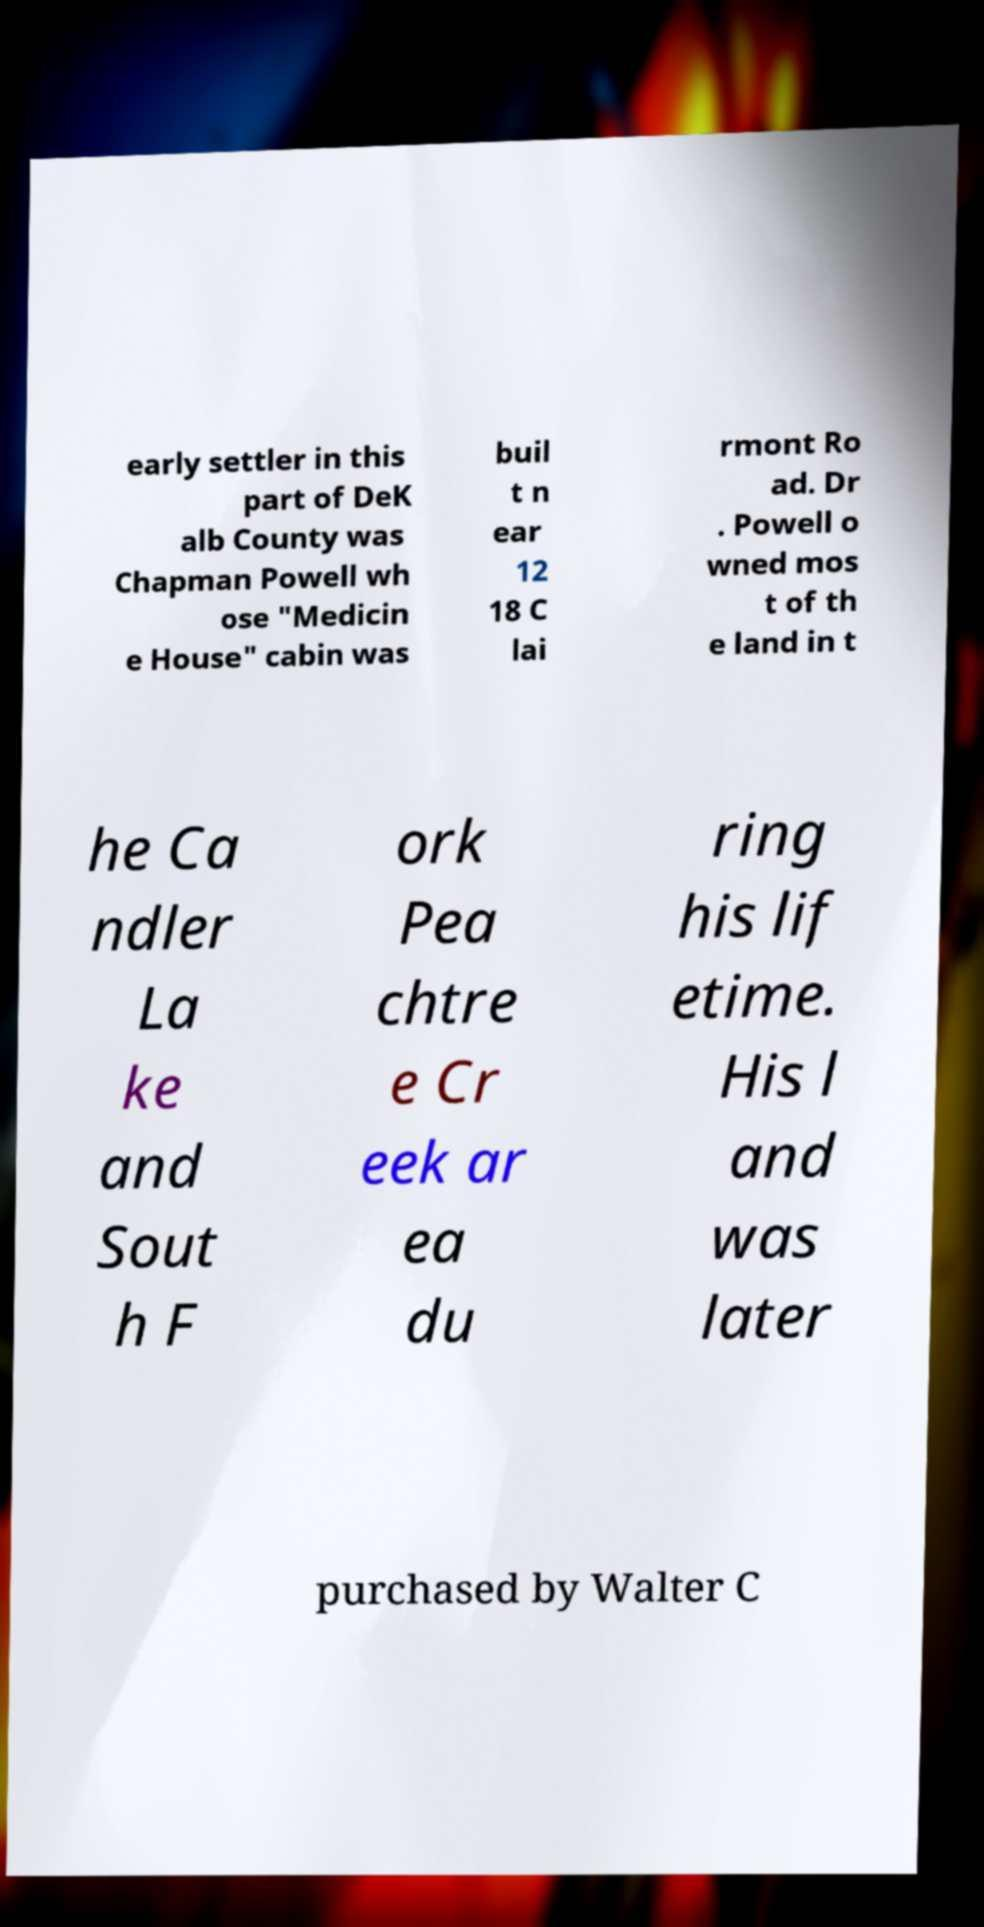Please identify and transcribe the text found in this image. early settler in this part of DeK alb County was Chapman Powell wh ose "Medicin e House" cabin was buil t n ear 12 18 C lai rmont Ro ad. Dr . Powell o wned mos t of th e land in t he Ca ndler La ke and Sout h F ork Pea chtre e Cr eek ar ea du ring his lif etime. His l and was later purchased by Walter C 